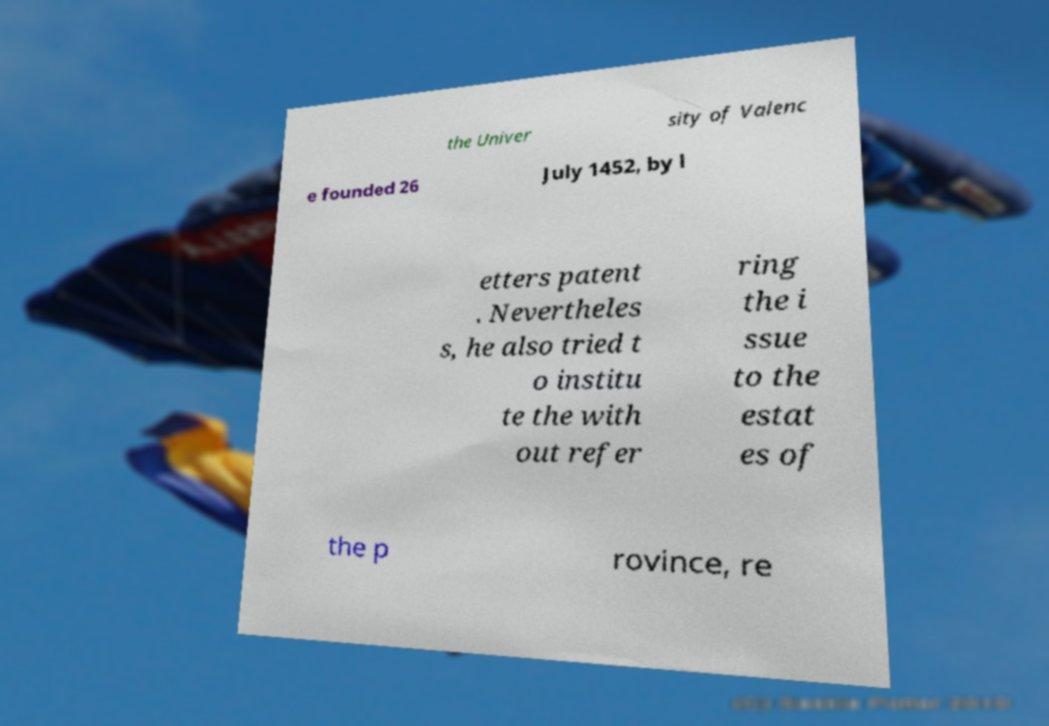There's text embedded in this image that I need extracted. Can you transcribe it verbatim? the Univer sity of Valenc e founded 26 July 1452, by l etters patent . Nevertheles s, he also tried t o institu te the with out refer ring the i ssue to the estat es of the p rovince, re 